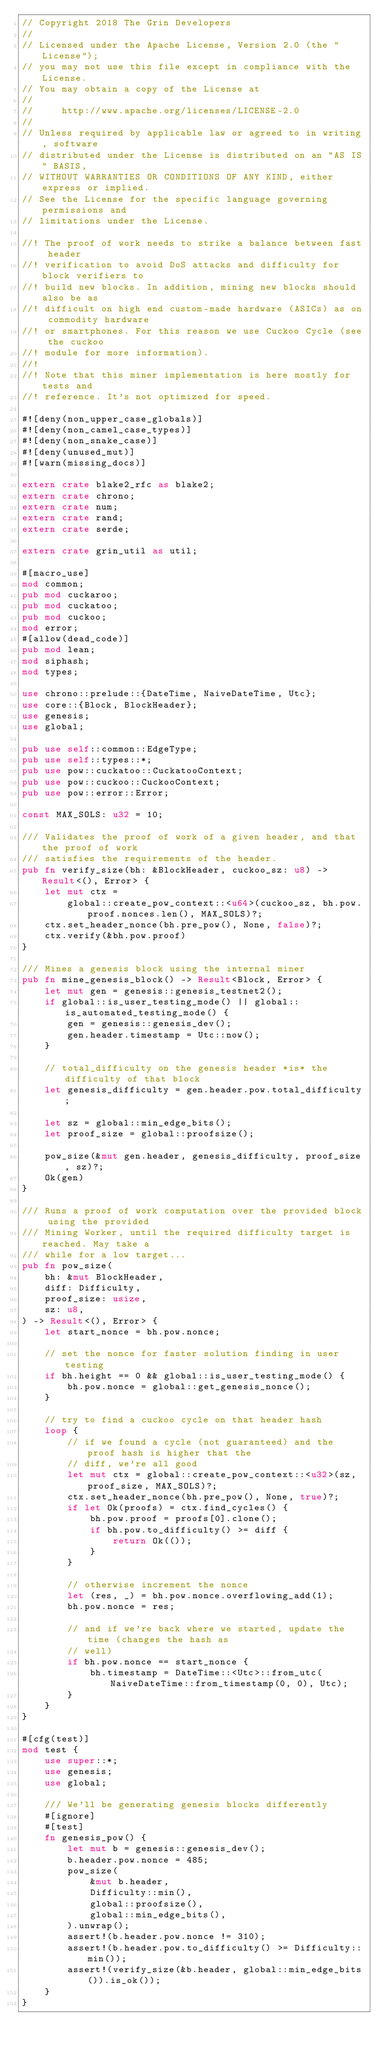<code> <loc_0><loc_0><loc_500><loc_500><_Rust_>// Copyright 2018 The Grin Developers
//
// Licensed under the Apache License, Version 2.0 (the "License");
// you may not use this file except in compliance with the License.
// You may obtain a copy of the License at
//
//     http://www.apache.org/licenses/LICENSE-2.0
//
// Unless required by applicable law or agreed to in writing, software
// distributed under the License is distributed on an "AS IS" BASIS,
// WITHOUT WARRANTIES OR CONDITIONS OF ANY KIND, either express or implied.
// See the License for the specific language governing permissions and
// limitations under the License.

//! The proof of work needs to strike a balance between fast header
//! verification to avoid DoS attacks and difficulty for block verifiers to
//! build new blocks. In addition, mining new blocks should also be as
//! difficult on high end custom-made hardware (ASICs) as on commodity hardware
//! or smartphones. For this reason we use Cuckoo Cycle (see the cuckoo
//! module for more information).
//!
//! Note that this miner implementation is here mostly for tests and
//! reference. It's not optimized for speed.

#![deny(non_upper_case_globals)]
#![deny(non_camel_case_types)]
#![deny(non_snake_case)]
#![deny(unused_mut)]
#![warn(missing_docs)]

extern crate blake2_rfc as blake2;
extern crate chrono;
extern crate num;
extern crate rand;
extern crate serde;

extern crate grin_util as util;

#[macro_use]
mod common;
pub mod cuckaroo;
pub mod cuckatoo;
pub mod cuckoo;
mod error;
#[allow(dead_code)]
pub mod lean;
mod siphash;
mod types;

use chrono::prelude::{DateTime, NaiveDateTime, Utc};
use core::{Block, BlockHeader};
use genesis;
use global;

pub use self::common::EdgeType;
pub use self::types::*;
pub use pow::cuckatoo::CuckatooContext;
pub use pow::cuckoo::CuckooContext;
pub use pow::error::Error;

const MAX_SOLS: u32 = 10;

/// Validates the proof of work of a given header, and that the proof of work
/// satisfies the requirements of the header.
pub fn verify_size(bh: &BlockHeader, cuckoo_sz: u8) -> Result<(), Error> {
	let mut ctx =
		global::create_pow_context::<u64>(cuckoo_sz, bh.pow.proof.nonces.len(), MAX_SOLS)?;
	ctx.set_header_nonce(bh.pre_pow(), None, false)?;
	ctx.verify(&bh.pow.proof)
}

/// Mines a genesis block using the internal miner
pub fn mine_genesis_block() -> Result<Block, Error> {
	let mut gen = genesis::genesis_testnet2();
	if global::is_user_testing_mode() || global::is_automated_testing_mode() {
		gen = genesis::genesis_dev();
		gen.header.timestamp = Utc::now();
	}

	// total_difficulty on the genesis header *is* the difficulty of that block
	let genesis_difficulty = gen.header.pow.total_difficulty;

	let sz = global::min_edge_bits();
	let proof_size = global::proofsize();

	pow_size(&mut gen.header, genesis_difficulty, proof_size, sz)?;
	Ok(gen)
}

/// Runs a proof of work computation over the provided block using the provided
/// Mining Worker, until the required difficulty target is reached. May take a
/// while for a low target...
pub fn pow_size(
	bh: &mut BlockHeader,
	diff: Difficulty,
	proof_size: usize,
	sz: u8,
) -> Result<(), Error> {
	let start_nonce = bh.pow.nonce;

	// set the nonce for faster solution finding in user testing
	if bh.height == 0 && global::is_user_testing_mode() {
		bh.pow.nonce = global::get_genesis_nonce();
	}

	// try to find a cuckoo cycle on that header hash
	loop {
		// if we found a cycle (not guaranteed) and the proof hash is higher that the
		// diff, we're all good
		let mut ctx = global::create_pow_context::<u32>(sz, proof_size, MAX_SOLS)?;
		ctx.set_header_nonce(bh.pre_pow(), None, true)?;
		if let Ok(proofs) = ctx.find_cycles() {
			bh.pow.proof = proofs[0].clone();
			if bh.pow.to_difficulty() >= diff {
				return Ok(());
			}
		}

		// otherwise increment the nonce
		let (res, _) = bh.pow.nonce.overflowing_add(1);
		bh.pow.nonce = res;

		// and if we're back where we started, update the time (changes the hash as
		// well)
		if bh.pow.nonce == start_nonce {
			bh.timestamp = DateTime::<Utc>::from_utc(NaiveDateTime::from_timestamp(0, 0), Utc);
		}
	}
}

#[cfg(test)]
mod test {
	use super::*;
	use genesis;
	use global;

	/// We'll be generating genesis blocks differently
	#[ignore]
	#[test]
	fn genesis_pow() {
		let mut b = genesis::genesis_dev();
		b.header.pow.nonce = 485;
		pow_size(
			&mut b.header,
			Difficulty::min(),
			global::proofsize(),
			global::min_edge_bits(),
		).unwrap();
		assert!(b.header.pow.nonce != 310);
		assert!(b.header.pow.to_difficulty() >= Difficulty::min());
		assert!(verify_size(&b.header, global::min_edge_bits()).is_ok());
	}
}
</code> 